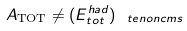Convert formula to latex. <formula><loc_0><loc_0><loc_500><loc_500>A _ { \text {TOT} } \neq ( E ^ { h a d } _ { t o t } ) _ { \ t e { n o n c m s } }</formula> 